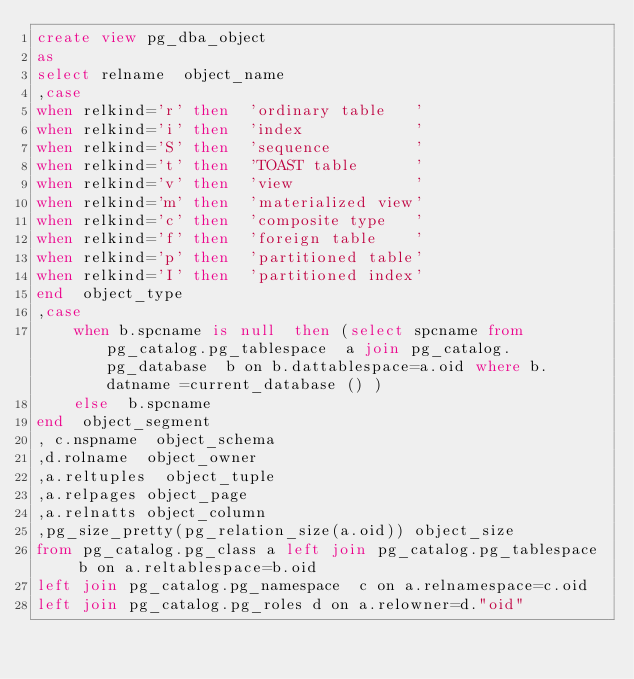<code> <loc_0><loc_0><loc_500><loc_500><_SQL_>create view pg_dba_object
as 
select relname  object_name
,case 
when relkind='r' then  'ordinary table   '
when relkind='i' then  'index            '
when relkind='S' then  'sequence         '
when relkind='t' then  'TOAST table      '
when relkind='v' then  'view             '
when relkind='m' then  'materialized view'
when relkind='c' then  'composite type   '
when relkind='f' then  'foreign table    '
when relkind='p' then  'partitioned table'
when relkind='I' then  'partitioned index'
end  object_type
,case 
	when b.spcname is null  then (select spcname from pg_catalog.pg_tablespace  a join pg_catalog.pg_database  b on b.dattablespace=a.oid where b.datname =current_database () )
	else  b.spcname 
end  object_segment
, c.nspname  object_schema
,d.rolname  object_owner
,a.reltuples  object_tuple
,a.relpages object_page
,a.relnatts object_column
,pg_size_pretty(pg_relation_size(a.oid)) object_size 
from pg_catalog.pg_class a left join pg_catalog.pg_tablespace  b on a.reltablespace=b.oid
left join pg_catalog.pg_namespace  c on a.relnamespace=c.oid 
left join pg_catalog.pg_roles d on a.relowner=d."oid" 
</code> 